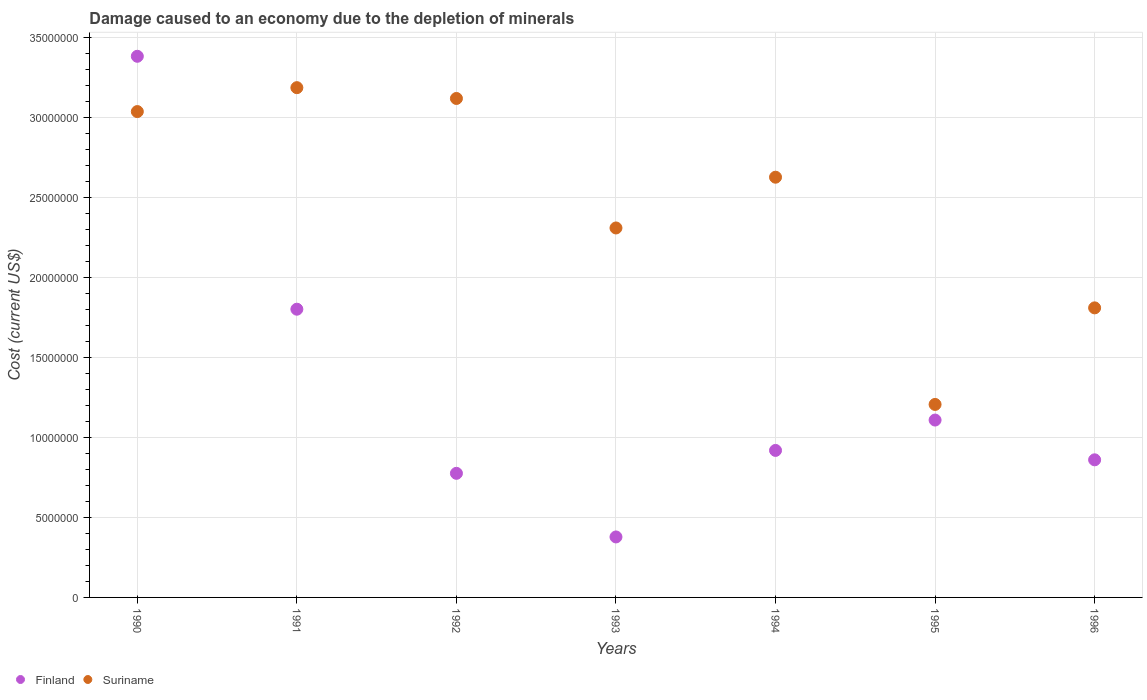How many different coloured dotlines are there?
Ensure brevity in your answer.  2. What is the cost of damage caused due to the depletion of minerals in Suriname in 1993?
Give a very brief answer. 2.31e+07. Across all years, what is the maximum cost of damage caused due to the depletion of minerals in Suriname?
Your answer should be compact. 3.18e+07. Across all years, what is the minimum cost of damage caused due to the depletion of minerals in Suriname?
Ensure brevity in your answer.  1.21e+07. What is the total cost of damage caused due to the depletion of minerals in Finland in the graph?
Your response must be concise. 9.22e+07. What is the difference between the cost of damage caused due to the depletion of minerals in Finland in 1992 and that in 1993?
Provide a short and direct response. 3.97e+06. What is the difference between the cost of damage caused due to the depletion of minerals in Finland in 1991 and the cost of damage caused due to the depletion of minerals in Suriname in 1995?
Your answer should be compact. 5.95e+06. What is the average cost of damage caused due to the depletion of minerals in Finland per year?
Your response must be concise. 1.32e+07. In the year 1994, what is the difference between the cost of damage caused due to the depletion of minerals in Finland and cost of damage caused due to the depletion of minerals in Suriname?
Keep it short and to the point. -1.71e+07. In how many years, is the cost of damage caused due to the depletion of minerals in Finland greater than 33000000 US$?
Your answer should be very brief. 1. What is the ratio of the cost of damage caused due to the depletion of minerals in Finland in 1991 to that in 1996?
Offer a very short reply. 2.09. Is the difference between the cost of damage caused due to the depletion of minerals in Finland in 1993 and 1996 greater than the difference between the cost of damage caused due to the depletion of minerals in Suriname in 1993 and 1996?
Give a very brief answer. No. What is the difference between the highest and the second highest cost of damage caused due to the depletion of minerals in Finland?
Provide a short and direct response. 1.58e+07. What is the difference between the highest and the lowest cost of damage caused due to the depletion of minerals in Suriname?
Make the answer very short. 1.98e+07. In how many years, is the cost of damage caused due to the depletion of minerals in Suriname greater than the average cost of damage caused due to the depletion of minerals in Suriname taken over all years?
Provide a succinct answer. 4. Is the cost of damage caused due to the depletion of minerals in Finland strictly less than the cost of damage caused due to the depletion of minerals in Suriname over the years?
Ensure brevity in your answer.  No. How many dotlines are there?
Give a very brief answer. 2. What is the difference between two consecutive major ticks on the Y-axis?
Give a very brief answer. 5.00e+06. Does the graph contain any zero values?
Offer a very short reply. No. Does the graph contain grids?
Your answer should be compact. Yes. How many legend labels are there?
Make the answer very short. 2. How are the legend labels stacked?
Offer a very short reply. Horizontal. What is the title of the graph?
Provide a succinct answer. Damage caused to an economy due to the depletion of minerals. What is the label or title of the X-axis?
Make the answer very short. Years. What is the label or title of the Y-axis?
Keep it short and to the point. Cost (current US$). What is the Cost (current US$) in Finland in 1990?
Keep it short and to the point. 3.38e+07. What is the Cost (current US$) in Suriname in 1990?
Your answer should be very brief. 3.04e+07. What is the Cost (current US$) of Finland in 1991?
Offer a very short reply. 1.80e+07. What is the Cost (current US$) of Suriname in 1991?
Offer a terse response. 3.18e+07. What is the Cost (current US$) in Finland in 1992?
Provide a short and direct response. 7.75e+06. What is the Cost (current US$) in Suriname in 1992?
Keep it short and to the point. 3.12e+07. What is the Cost (current US$) in Finland in 1993?
Your answer should be very brief. 3.78e+06. What is the Cost (current US$) of Suriname in 1993?
Ensure brevity in your answer.  2.31e+07. What is the Cost (current US$) of Finland in 1994?
Your answer should be compact. 9.18e+06. What is the Cost (current US$) of Suriname in 1994?
Provide a succinct answer. 2.63e+07. What is the Cost (current US$) in Finland in 1995?
Ensure brevity in your answer.  1.11e+07. What is the Cost (current US$) of Suriname in 1995?
Offer a terse response. 1.21e+07. What is the Cost (current US$) of Finland in 1996?
Offer a very short reply. 8.60e+06. What is the Cost (current US$) of Suriname in 1996?
Your answer should be compact. 1.81e+07. Across all years, what is the maximum Cost (current US$) in Finland?
Provide a short and direct response. 3.38e+07. Across all years, what is the maximum Cost (current US$) in Suriname?
Your answer should be compact. 3.18e+07. Across all years, what is the minimum Cost (current US$) of Finland?
Give a very brief answer. 3.78e+06. Across all years, what is the minimum Cost (current US$) in Suriname?
Provide a succinct answer. 1.21e+07. What is the total Cost (current US$) in Finland in the graph?
Your answer should be very brief. 9.22e+07. What is the total Cost (current US$) of Suriname in the graph?
Make the answer very short. 1.73e+08. What is the difference between the Cost (current US$) of Finland in 1990 and that in 1991?
Provide a succinct answer. 1.58e+07. What is the difference between the Cost (current US$) in Suriname in 1990 and that in 1991?
Your answer should be compact. -1.49e+06. What is the difference between the Cost (current US$) of Finland in 1990 and that in 1992?
Ensure brevity in your answer.  2.61e+07. What is the difference between the Cost (current US$) of Suriname in 1990 and that in 1992?
Give a very brief answer. -8.19e+05. What is the difference between the Cost (current US$) in Finland in 1990 and that in 1993?
Give a very brief answer. 3.00e+07. What is the difference between the Cost (current US$) of Suriname in 1990 and that in 1993?
Ensure brevity in your answer.  7.27e+06. What is the difference between the Cost (current US$) of Finland in 1990 and that in 1994?
Provide a short and direct response. 2.46e+07. What is the difference between the Cost (current US$) of Suriname in 1990 and that in 1994?
Provide a succinct answer. 4.10e+06. What is the difference between the Cost (current US$) in Finland in 1990 and that in 1995?
Make the answer very short. 2.27e+07. What is the difference between the Cost (current US$) in Suriname in 1990 and that in 1995?
Your answer should be very brief. 1.83e+07. What is the difference between the Cost (current US$) in Finland in 1990 and that in 1996?
Your answer should be compact. 2.52e+07. What is the difference between the Cost (current US$) of Suriname in 1990 and that in 1996?
Your answer should be compact. 1.23e+07. What is the difference between the Cost (current US$) in Finland in 1991 and that in 1992?
Offer a terse response. 1.03e+07. What is the difference between the Cost (current US$) in Suriname in 1991 and that in 1992?
Offer a terse response. 6.75e+05. What is the difference between the Cost (current US$) in Finland in 1991 and that in 1993?
Keep it short and to the point. 1.42e+07. What is the difference between the Cost (current US$) in Suriname in 1991 and that in 1993?
Offer a terse response. 8.76e+06. What is the difference between the Cost (current US$) in Finland in 1991 and that in 1994?
Your response must be concise. 8.82e+06. What is the difference between the Cost (current US$) in Suriname in 1991 and that in 1994?
Provide a short and direct response. 5.59e+06. What is the difference between the Cost (current US$) of Finland in 1991 and that in 1995?
Your answer should be compact. 6.93e+06. What is the difference between the Cost (current US$) of Suriname in 1991 and that in 1995?
Your answer should be compact. 1.98e+07. What is the difference between the Cost (current US$) in Finland in 1991 and that in 1996?
Make the answer very short. 9.41e+06. What is the difference between the Cost (current US$) in Suriname in 1991 and that in 1996?
Your answer should be very brief. 1.38e+07. What is the difference between the Cost (current US$) of Finland in 1992 and that in 1993?
Your answer should be very brief. 3.97e+06. What is the difference between the Cost (current US$) of Suriname in 1992 and that in 1993?
Offer a very short reply. 8.09e+06. What is the difference between the Cost (current US$) in Finland in 1992 and that in 1994?
Provide a succinct answer. -1.43e+06. What is the difference between the Cost (current US$) in Suriname in 1992 and that in 1994?
Offer a very short reply. 4.92e+06. What is the difference between the Cost (current US$) of Finland in 1992 and that in 1995?
Your response must be concise. -3.33e+06. What is the difference between the Cost (current US$) of Suriname in 1992 and that in 1995?
Provide a succinct answer. 1.91e+07. What is the difference between the Cost (current US$) in Finland in 1992 and that in 1996?
Keep it short and to the point. -8.44e+05. What is the difference between the Cost (current US$) of Suriname in 1992 and that in 1996?
Your answer should be very brief. 1.31e+07. What is the difference between the Cost (current US$) of Finland in 1993 and that in 1994?
Your response must be concise. -5.41e+06. What is the difference between the Cost (current US$) of Suriname in 1993 and that in 1994?
Ensure brevity in your answer.  -3.17e+06. What is the difference between the Cost (current US$) of Finland in 1993 and that in 1995?
Provide a succinct answer. -7.30e+06. What is the difference between the Cost (current US$) in Suriname in 1993 and that in 1995?
Your answer should be compact. 1.10e+07. What is the difference between the Cost (current US$) of Finland in 1993 and that in 1996?
Your answer should be compact. -4.82e+06. What is the difference between the Cost (current US$) of Suriname in 1993 and that in 1996?
Give a very brief answer. 4.99e+06. What is the difference between the Cost (current US$) of Finland in 1994 and that in 1995?
Your answer should be compact. -1.90e+06. What is the difference between the Cost (current US$) of Suriname in 1994 and that in 1995?
Make the answer very short. 1.42e+07. What is the difference between the Cost (current US$) in Finland in 1994 and that in 1996?
Give a very brief answer. 5.88e+05. What is the difference between the Cost (current US$) of Suriname in 1994 and that in 1996?
Ensure brevity in your answer.  8.16e+06. What is the difference between the Cost (current US$) in Finland in 1995 and that in 1996?
Give a very brief answer. 2.48e+06. What is the difference between the Cost (current US$) of Suriname in 1995 and that in 1996?
Keep it short and to the point. -6.03e+06. What is the difference between the Cost (current US$) of Finland in 1990 and the Cost (current US$) of Suriname in 1991?
Your answer should be very brief. 1.96e+06. What is the difference between the Cost (current US$) in Finland in 1990 and the Cost (current US$) in Suriname in 1992?
Provide a short and direct response. 2.64e+06. What is the difference between the Cost (current US$) in Finland in 1990 and the Cost (current US$) in Suriname in 1993?
Your response must be concise. 1.07e+07. What is the difference between the Cost (current US$) of Finland in 1990 and the Cost (current US$) of Suriname in 1994?
Your answer should be very brief. 7.55e+06. What is the difference between the Cost (current US$) in Finland in 1990 and the Cost (current US$) in Suriname in 1995?
Provide a succinct answer. 2.17e+07. What is the difference between the Cost (current US$) of Finland in 1990 and the Cost (current US$) of Suriname in 1996?
Your answer should be compact. 1.57e+07. What is the difference between the Cost (current US$) in Finland in 1991 and the Cost (current US$) in Suriname in 1992?
Make the answer very short. -1.32e+07. What is the difference between the Cost (current US$) of Finland in 1991 and the Cost (current US$) of Suriname in 1993?
Offer a terse response. -5.08e+06. What is the difference between the Cost (current US$) of Finland in 1991 and the Cost (current US$) of Suriname in 1994?
Make the answer very short. -8.25e+06. What is the difference between the Cost (current US$) in Finland in 1991 and the Cost (current US$) in Suriname in 1995?
Provide a short and direct response. 5.95e+06. What is the difference between the Cost (current US$) of Finland in 1991 and the Cost (current US$) of Suriname in 1996?
Give a very brief answer. -8.33e+04. What is the difference between the Cost (current US$) of Finland in 1992 and the Cost (current US$) of Suriname in 1993?
Make the answer very short. -1.53e+07. What is the difference between the Cost (current US$) in Finland in 1992 and the Cost (current US$) in Suriname in 1994?
Your answer should be compact. -1.85e+07. What is the difference between the Cost (current US$) of Finland in 1992 and the Cost (current US$) of Suriname in 1995?
Keep it short and to the point. -4.30e+06. What is the difference between the Cost (current US$) in Finland in 1992 and the Cost (current US$) in Suriname in 1996?
Make the answer very short. -1.03e+07. What is the difference between the Cost (current US$) of Finland in 1993 and the Cost (current US$) of Suriname in 1994?
Your answer should be very brief. -2.25e+07. What is the difference between the Cost (current US$) of Finland in 1993 and the Cost (current US$) of Suriname in 1995?
Offer a terse response. -8.28e+06. What is the difference between the Cost (current US$) in Finland in 1993 and the Cost (current US$) in Suriname in 1996?
Your answer should be compact. -1.43e+07. What is the difference between the Cost (current US$) of Finland in 1994 and the Cost (current US$) of Suriname in 1995?
Your response must be concise. -2.87e+06. What is the difference between the Cost (current US$) in Finland in 1994 and the Cost (current US$) in Suriname in 1996?
Your answer should be compact. -8.91e+06. What is the difference between the Cost (current US$) in Finland in 1995 and the Cost (current US$) in Suriname in 1996?
Provide a short and direct response. -7.01e+06. What is the average Cost (current US$) in Finland per year?
Your answer should be compact. 1.32e+07. What is the average Cost (current US$) in Suriname per year?
Your answer should be very brief. 2.47e+07. In the year 1990, what is the difference between the Cost (current US$) of Finland and Cost (current US$) of Suriname?
Provide a short and direct response. 3.45e+06. In the year 1991, what is the difference between the Cost (current US$) of Finland and Cost (current US$) of Suriname?
Your response must be concise. -1.38e+07. In the year 1992, what is the difference between the Cost (current US$) in Finland and Cost (current US$) in Suriname?
Offer a terse response. -2.34e+07. In the year 1993, what is the difference between the Cost (current US$) in Finland and Cost (current US$) in Suriname?
Your response must be concise. -1.93e+07. In the year 1994, what is the difference between the Cost (current US$) of Finland and Cost (current US$) of Suriname?
Offer a terse response. -1.71e+07. In the year 1995, what is the difference between the Cost (current US$) of Finland and Cost (current US$) of Suriname?
Your response must be concise. -9.76e+05. In the year 1996, what is the difference between the Cost (current US$) of Finland and Cost (current US$) of Suriname?
Provide a short and direct response. -9.49e+06. What is the ratio of the Cost (current US$) in Finland in 1990 to that in 1991?
Give a very brief answer. 1.88. What is the ratio of the Cost (current US$) of Suriname in 1990 to that in 1991?
Give a very brief answer. 0.95. What is the ratio of the Cost (current US$) of Finland in 1990 to that in 1992?
Your answer should be very brief. 4.36. What is the ratio of the Cost (current US$) in Suriname in 1990 to that in 1992?
Offer a very short reply. 0.97. What is the ratio of the Cost (current US$) in Finland in 1990 to that in 1993?
Ensure brevity in your answer.  8.95. What is the ratio of the Cost (current US$) in Suriname in 1990 to that in 1993?
Provide a succinct answer. 1.31. What is the ratio of the Cost (current US$) in Finland in 1990 to that in 1994?
Make the answer very short. 3.68. What is the ratio of the Cost (current US$) in Suriname in 1990 to that in 1994?
Your answer should be compact. 1.16. What is the ratio of the Cost (current US$) of Finland in 1990 to that in 1995?
Provide a succinct answer. 3.05. What is the ratio of the Cost (current US$) in Suriname in 1990 to that in 1995?
Your response must be concise. 2.52. What is the ratio of the Cost (current US$) in Finland in 1990 to that in 1996?
Keep it short and to the point. 3.93. What is the ratio of the Cost (current US$) in Suriname in 1990 to that in 1996?
Ensure brevity in your answer.  1.68. What is the ratio of the Cost (current US$) of Finland in 1991 to that in 1992?
Your answer should be compact. 2.32. What is the ratio of the Cost (current US$) in Suriname in 1991 to that in 1992?
Your response must be concise. 1.02. What is the ratio of the Cost (current US$) of Finland in 1991 to that in 1993?
Your answer should be compact. 4.76. What is the ratio of the Cost (current US$) of Suriname in 1991 to that in 1993?
Give a very brief answer. 1.38. What is the ratio of the Cost (current US$) of Finland in 1991 to that in 1994?
Give a very brief answer. 1.96. What is the ratio of the Cost (current US$) of Suriname in 1991 to that in 1994?
Provide a succinct answer. 1.21. What is the ratio of the Cost (current US$) of Finland in 1991 to that in 1995?
Give a very brief answer. 1.62. What is the ratio of the Cost (current US$) of Suriname in 1991 to that in 1995?
Keep it short and to the point. 2.64. What is the ratio of the Cost (current US$) of Finland in 1991 to that in 1996?
Provide a succinct answer. 2.09. What is the ratio of the Cost (current US$) in Suriname in 1991 to that in 1996?
Make the answer very short. 1.76. What is the ratio of the Cost (current US$) of Finland in 1992 to that in 1993?
Your answer should be very brief. 2.05. What is the ratio of the Cost (current US$) in Suriname in 1992 to that in 1993?
Give a very brief answer. 1.35. What is the ratio of the Cost (current US$) in Finland in 1992 to that in 1994?
Provide a succinct answer. 0.84. What is the ratio of the Cost (current US$) of Suriname in 1992 to that in 1994?
Offer a very short reply. 1.19. What is the ratio of the Cost (current US$) in Finland in 1992 to that in 1995?
Offer a terse response. 0.7. What is the ratio of the Cost (current US$) in Suriname in 1992 to that in 1995?
Keep it short and to the point. 2.59. What is the ratio of the Cost (current US$) of Finland in 1992 to that in 1996?
Your response must be concise. 0.9. What is the ratio of the Cost (current US$) in Suriname in 1992 to that in 1996?
Offer a terse response. 1.72. What is the ratio of the Cost (current US$) of Finland in 1993 to that in 1994?
Keep it short and to the point. 0.41. What is the ratio of the Cost (current US$) in Suriname in 1993 to that in 1994?
Make the answer very short. 0.88. What is the ratio of the Cost (current US$) in Finland in 1993 to that in 1995?
Your answer should be compact. 0.34. What is the ratio of the Cost (current US$) of Suriname in 1993 to that in 1995?
Your response must be concise. 1.91. What is the ratio of the Cost (current US$) of Finland in 1993 to that in 1996?
Provide a short and direct response. 0.44. What is the ratio of the Cost (current US$) in Suriname in 1993 to that in 1996?
Give a very brief answer. 1.28. What is the ratio of the Cost (current US$) in Finland in 1994 to that in 1995?
Make the answer very short. 0.83. What is the ratio of the Cost (current US$) of Suriname in 1994 to that in 1995?
Provide a short and direct response. 2.18. What is the ratio of the Cost (current US$) in Finland in 1994 to that in 1996?
Offer a very short reply. 1.07. What is the ratio of the Cost (current US$) in Suriname in 1994 to that in 1996?
Keep it short and to the point. 1.45. What is the ratio of the Cost (current US$) in Finland in 1995 to that in 1996?
Keep it short and to the point. 1.29. What is the ratio of the Cost (current US$) of Suriname in 1995 to that in 1996?
Provide a short and direct response. 0.67. What is the difference between the highest and the second highest Cost (current US$) of Finland?
Your response must be concise. 1.58e+07. What is the difference between the highest and the second highest Cost (current US$) of Suriname?
Offer a terse response. 6.75e+05. What is the difference between the highest and the lowest Cost (current US$) in Finland?
Your answer should be very brief. 3.00e+07. What is the difference between the highest and the lowest Cost (current US$) of Suriname?
Give a very brief answer. 1.98e+07. 